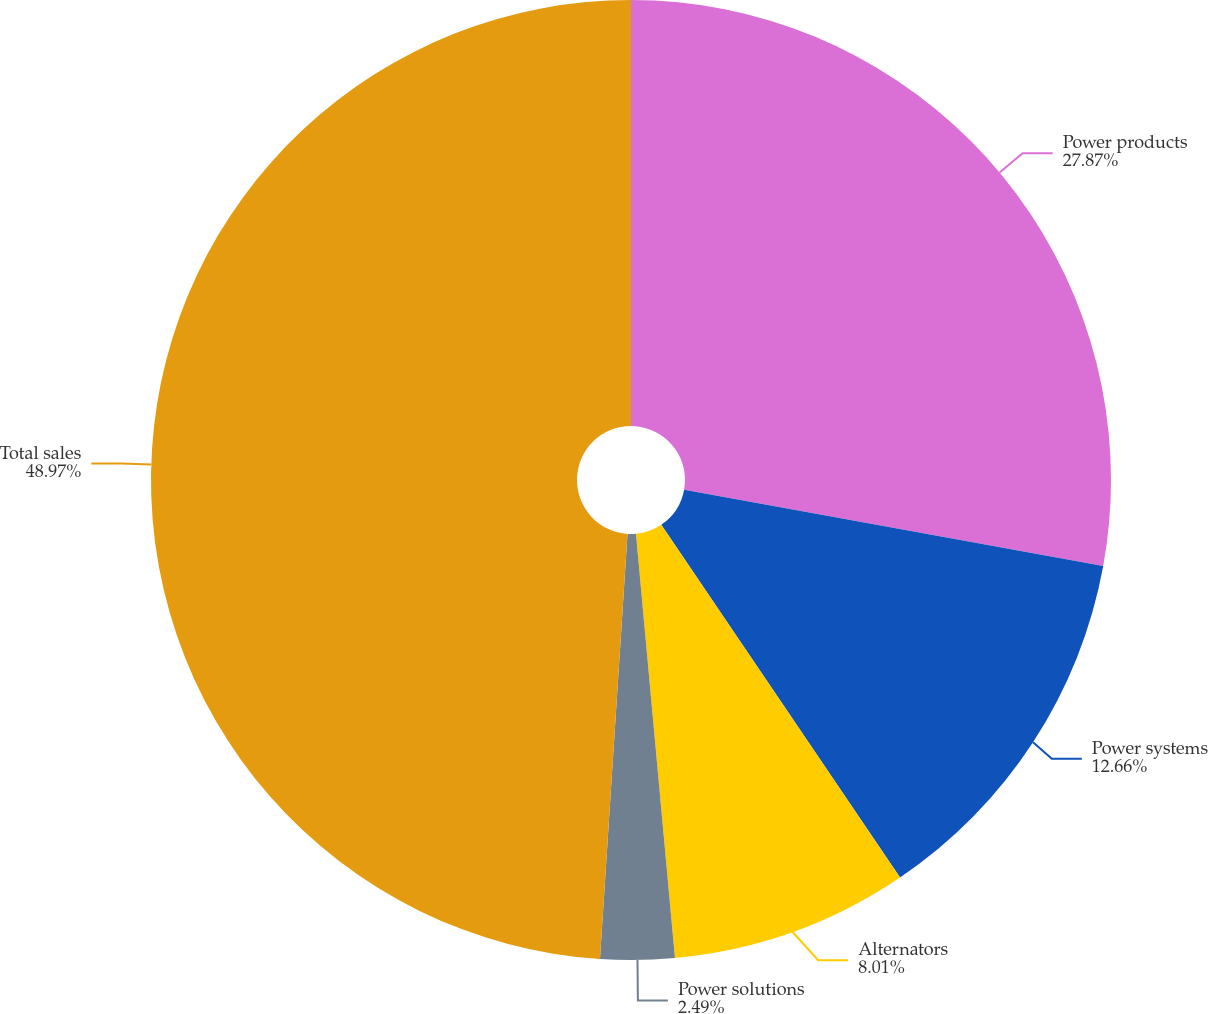Convert chart to OTSL. <chart><loc_0><loc_0><loc_500><loc_500><pie_chart><fcel>Power products<fcel>Power systems<fcel>Alternators<fcel>Power solutions<fcel>Total sales<nl><fcel>27.87%<fcel>12.66%<fcel>8.01%<fcel>2.49%<fcel>48.97%<nl></chart> 